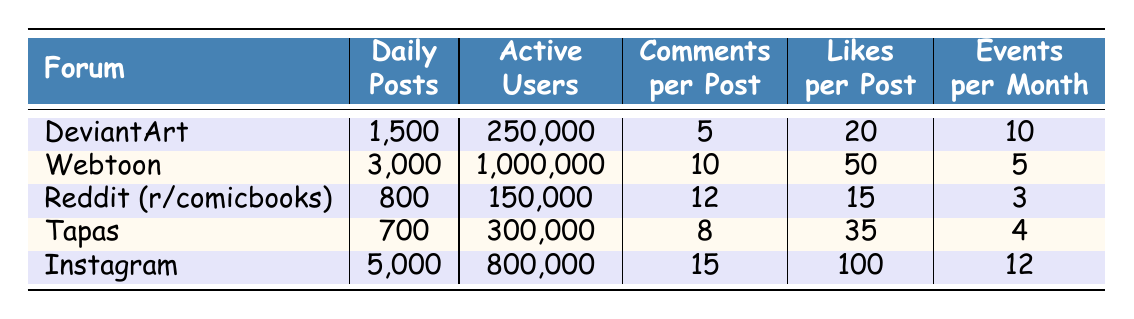What is the forum with the highest average daily posts? By comparing the values in the "Daily Posts" column, Webtoon has 3000 posts, which is greater than the others. DeviantArt has 1500, Reddit has 800, Tapas has 700, and Instagram has 5000, but thus that means Instagram has the highest daily posts overall.
Answer: Instagram How many active users does Tapas have? The "Active Users" column shows that Tapas has 300,000 active users.
Answer: 300,000 Which forum has the highest average likes per post? Looking at the "Likes per Post" column, Instagram has 100 likes per post, which is higher than the others (DeviantArt has 20, Webtoon has 50, Reddit has 15, and Tapas has 35).
Answer: Instagram What is the total number of events per month across all forums? To find the total, we sum the values in the "Events per Month" column: 10 (DeviantArt) + 5 (Webtoon) + 3 (Reddit) + 4 (Tapas) + 12 (Instagram) = 34.
Answer: 34 Is it true that Reddit has more active users than Tapas? By comparing the values in the "Active Users" column, Reddit has 150,000 active users while Tapas has 300,000. Therefore, it is false.
Answer: No What is the average number of comments per post among these forums? To calculate the average, we sum the "Comments per Post": 5 (DeviantArt) + 10 (Webtoon) + 12 (Reddit) + 8 (Tapas) + 15 (Instagram) = 50. There are 5 forums, so the average is 50/5 = 10.
Answer: 10 Which forum has the lowest number of average daily posts? Comparing the "Daily Posts", Tapas has the lowest with 700 posts, while DeviantArt has 1500, Webtoon has 3000, Reddit has 800, and Instagram has 5000.
Answer: Tapas What is the difference in average comments per post between Webtoon and Reddit? Webtoon has 10 comments per post and Reddit has 12, therefore the difference is 12 - 10 = 2.
Answer: 2 Which forum has both the highest number of likes per post and events per month? By looking at the "Likes per Post" and "Events per Month" columns, Instagram has 100 likes per post and 12 events per month, which are the highest in both categories compared to others.
Answer: Instagram 